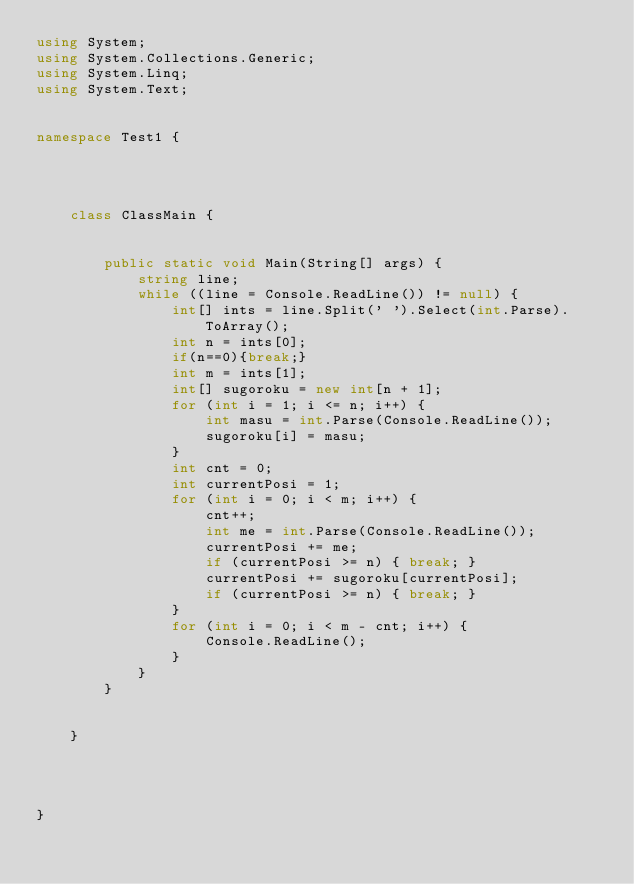<code> <loc_0><loc_0><loc_500><loc_500><_C#_>using System;
using System.Collections.Generic;
using System.Linq;
using System.Text;


namespace Test1 {

    


    class ClassMain {

       
        public static void Main(String[] args) {
            string line;
            while ((line = Console.ReadLine()) != null) {
                int[] ints = line.Split(' ').Select(int.Parse).ToArray();
                int n = ints[0];
                if(n==0){break;}
                int m = ints[1];
                int[] sugoroku = new int[n + 1];
                for (int i = 1; i <= n; i++) {
                    int masu = int.Parse(Console.ReadLine());
                    sugoroku[i] = masu;
                }
                int cnt = 0;
                int currentPosi = 1;
                for (int i = 0; i < m; i++) {
                    cnt++;
                    int me = int.Parse(Console.ReadLine());
                    currentPosi += me;
                    if (currentPosi >= n) { break; }
                    currentPosi += sugoroku[currentPosi];
                    if (currentPosi >= n) { break; }
                }
                for (int i = 0; i < m - cnt; i++) {
                    Console.ReadLine();
                }
            }
        }

        
    }



    
}</code> 